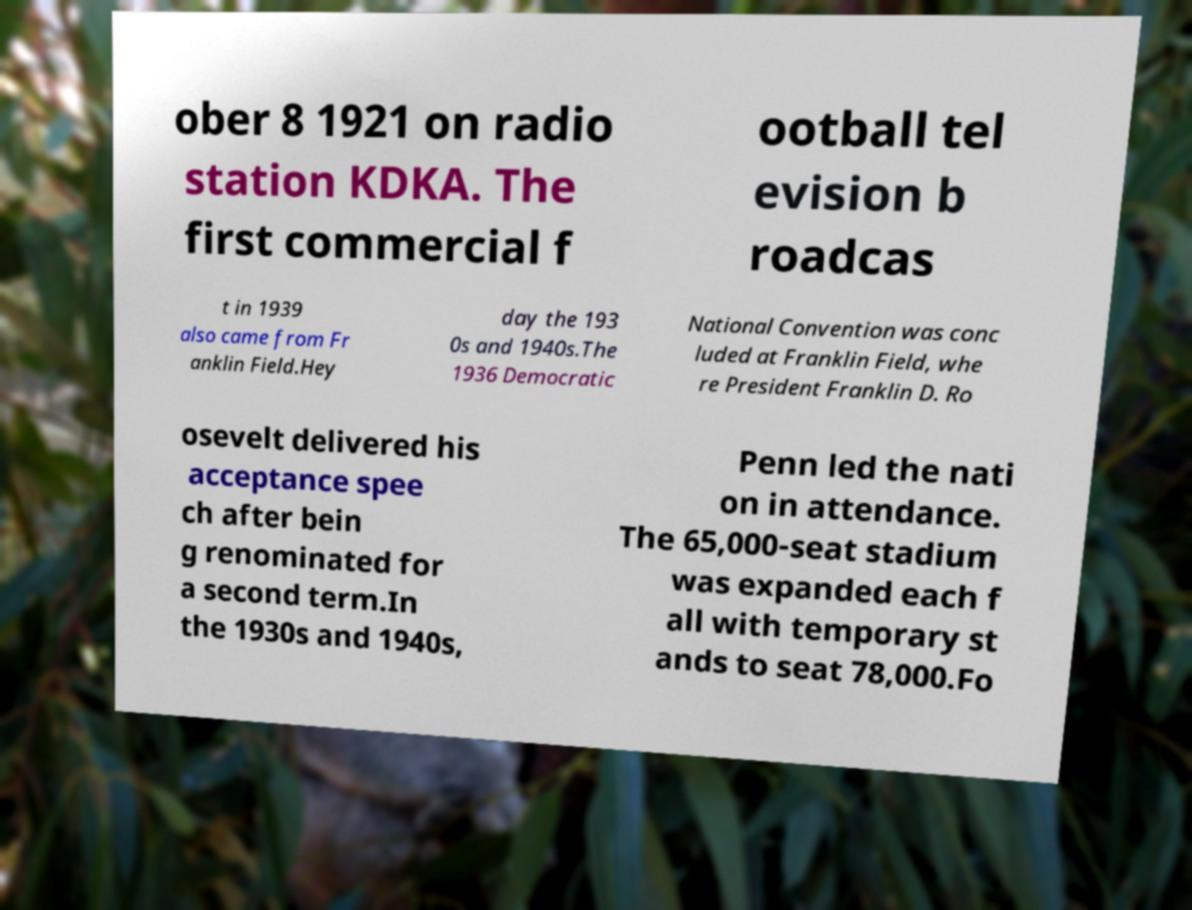Can you accurately transcribe the text from the provided image for me? ober 8 1921 on radio station KDKA. The first commercial f ootball tel evision b roadcas t in 1939 also came from Fr anklin Field.Hey day the 193 0s and 1940s.The 1936 Democratic National Convention was conc luded at Franklin Field, whe re President Franklin D. Ro osevelt delivered his acceptance spee ch after bein g renominated for a second term.In the 1930s and 1940s, Penn led the nati on in attendance. The 65,000-seat stadium was expanded each f all with temporary st ands to seat 78,000.Fo 